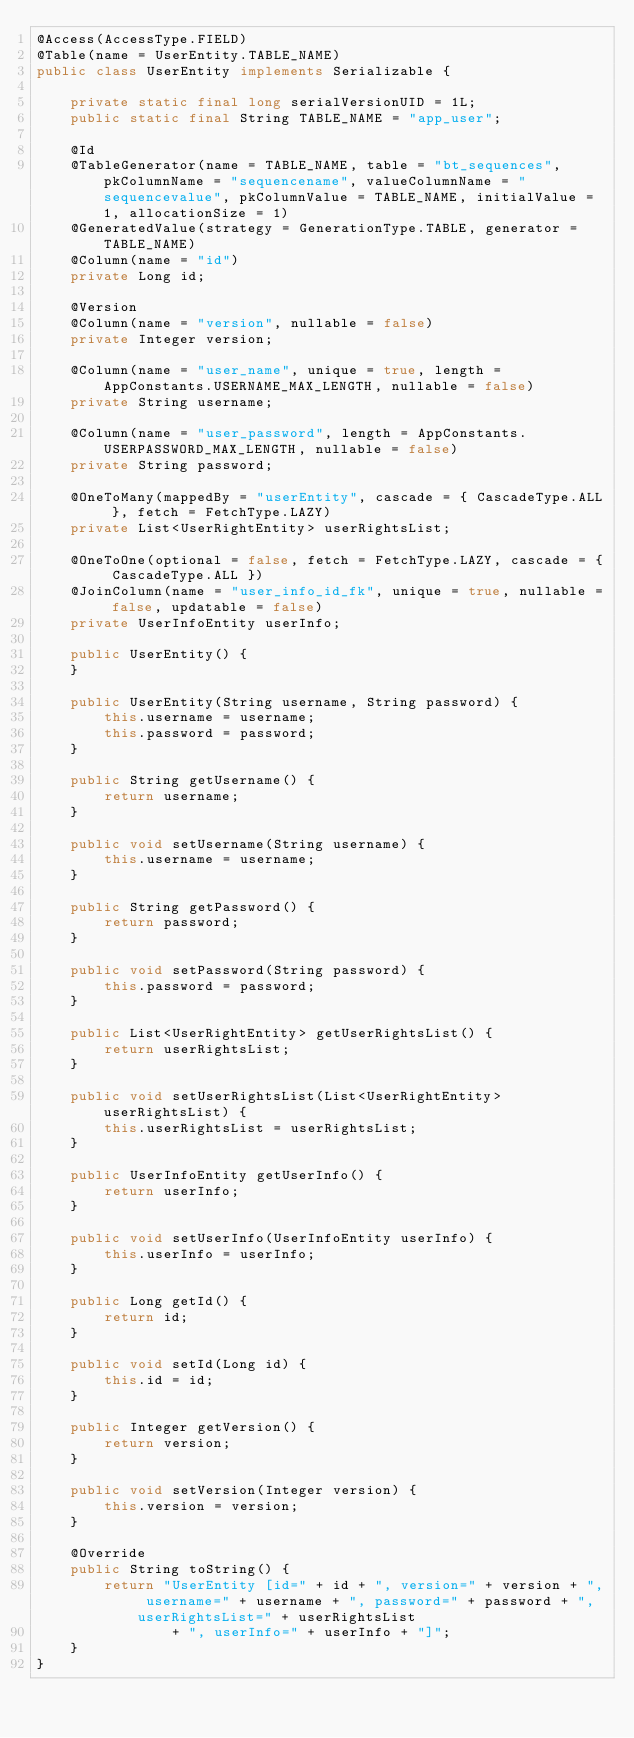Convert code to text. <code><loc_0><loc_0><loc_500><loc_500><_Java_>@Access(AccessType.FIELD)
@Table(name = UserEntity.TABLE_NAME)
public class UserEntity implements Serializable {

	private static final long serialVersionUID = 1L;
	public static final String TABLE_NAME = "app_user";

	@Id
	@TableGenerator(name = TABLE_NAME, table = "bt_sequences", pkColumnName = "sequencename", valueColumnName = "sequencevalue", pkColumnValue = TABLE_NAME, initialValue = 1, allocationSize = 1)
	@GeneratedValue(strategy = GenerationType.TABLE, generator = TABLE_NAME)
	@Column(name = "id")
	private Long id;

	@Version
	@Column(name = "version", nullable = false)
	private Integer version;

	@Column(name = "user_name", unique = true, length = AppConstants.USERNAME_MAX_LENGTH, nullable = false)
	private String username;

	@Column(name = "user_password", length = AppConstants.USERPASSWORD_MAX_LENGTH, nullable = false)
	private String password;

	@OneToMany(mappedBy = "userEntity", cascade = { CascadeType.ALL }, fetch = FetchType.LAZY)
	private List<UserRightEntity> userRightsList;

	@OneToOne(optional = false, fetch = FetchType.LAZY, cascade = { CascadeType.ALL })
	@JoinColumn(name = "user_info_id_fk", unique = true, nullable = false, updatable = false)
	private UserInfoEntity userInfo;

	public UserEntity() {
	}

	public UserEntity(String username, String password) {
		this.username = username;
		this.password = password;
	}

	public String getUsername() {
		return username;
	}

	public void setUsername(String username) {
		this.username = username;
	}

	public String getPassword() {
		return password;
	}

	public void setPassword(String password) {
		this.password = password;
	}

	public List<UserRightEntity> getUserRightsList() {
		return userRightsList;
	}

	public void setUserRightsList(List<UserRightEntity> userRightsList) {
		this.userRightsList = userRightsList;
	}

	public UserInfoEntity getUserInfo() {
		return userInfo;
	}

	public void setUserInfo(UserInfoEntity userInfo) {
		this.userInfo = userInfo;
	}

	public Long getId() {
		return id;
	}

	public void setId(Long id) {
		this.id = id;
	}

	public Integer getVersion() {
		return version;
	}

	public void setVersion(Integer version) {
		this.version = version;
	}

	@Override
	public String toString() {
		return "UserEntity [id=" + id + ", version=" + version + ", username=" + username + ", password=" + password + ", userRightsList=" + userRightsList
				+ ", userInfo=" + userInfo + "]";
	}
}
</code> 